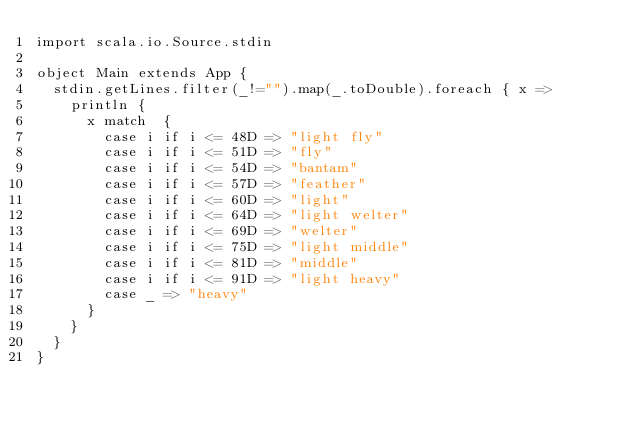Convert code to text. <code><loc_0><loc_0><loc_500><loc_500><_Scala_>import scala.io.Source.stdin

object Main extends App {
  stdin.getLines.filter(_!="").map(_.toDouble).foreach { x =>
    println {
      x match  {
        case i if i <= 48D => "light fly"
        case i if i <= 51D => "fly"
        case i if i <= 54D => "bantam"
        case i if i <= 57D => "feather"
        case i if i <= 60D => "light"
        case i if i <= 64D => "light welter"
        case i if i <= 69D => "welter"
        case i if i <= 75D => "light middle"
        case i if i <= 81D => "middle"
        case i if i <= 91D => "light heavy"
        case _ => "heavy"
      }
    }
  }
}</code> 